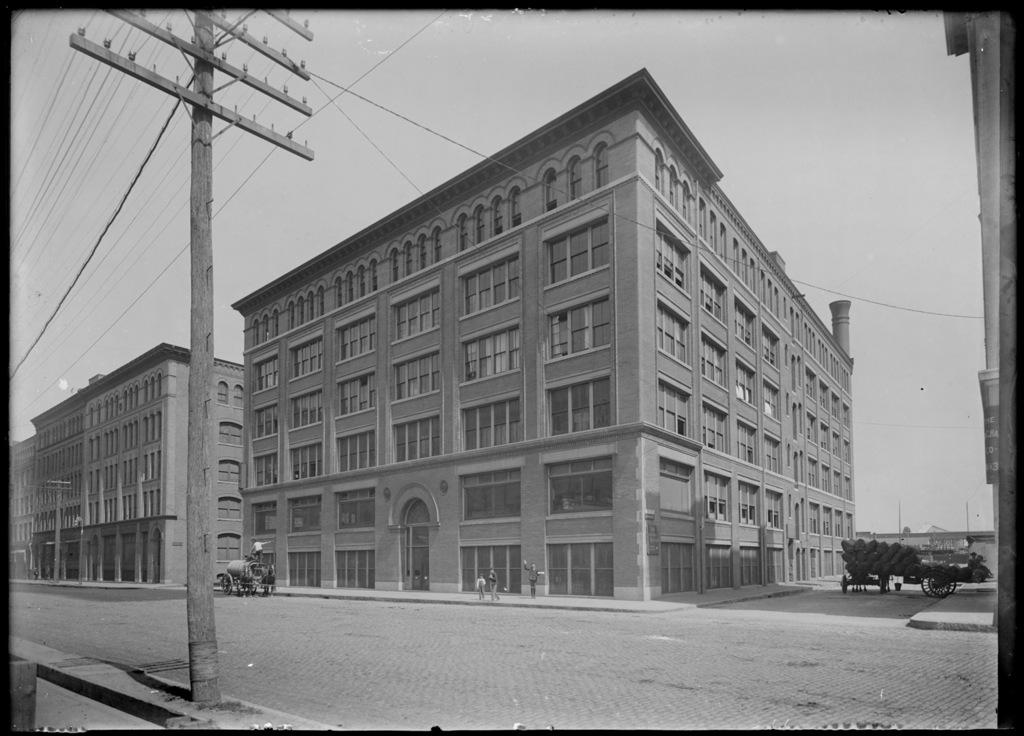What type of structures can be seen in the image? There are buildings in the image. What else can be seen moving in the image? There are vehicles in the image. Are there any living beings present in the image? Yes, there are people in the image. What is the main pathway visible in the image? There is a road in the image. What are the tall, thin structures with wires on them? There are electric poles in the image. What are the wires connecting the electric poles? There are cables in the image. What can be seen above the buildings and vehicles? The sky is visible in the image. Where is the plate of fish located in the image? There is no plate of fish present in the image. What type of cord is being used by the people in the image? There are no cords or any specific cord mentioned in the image. 